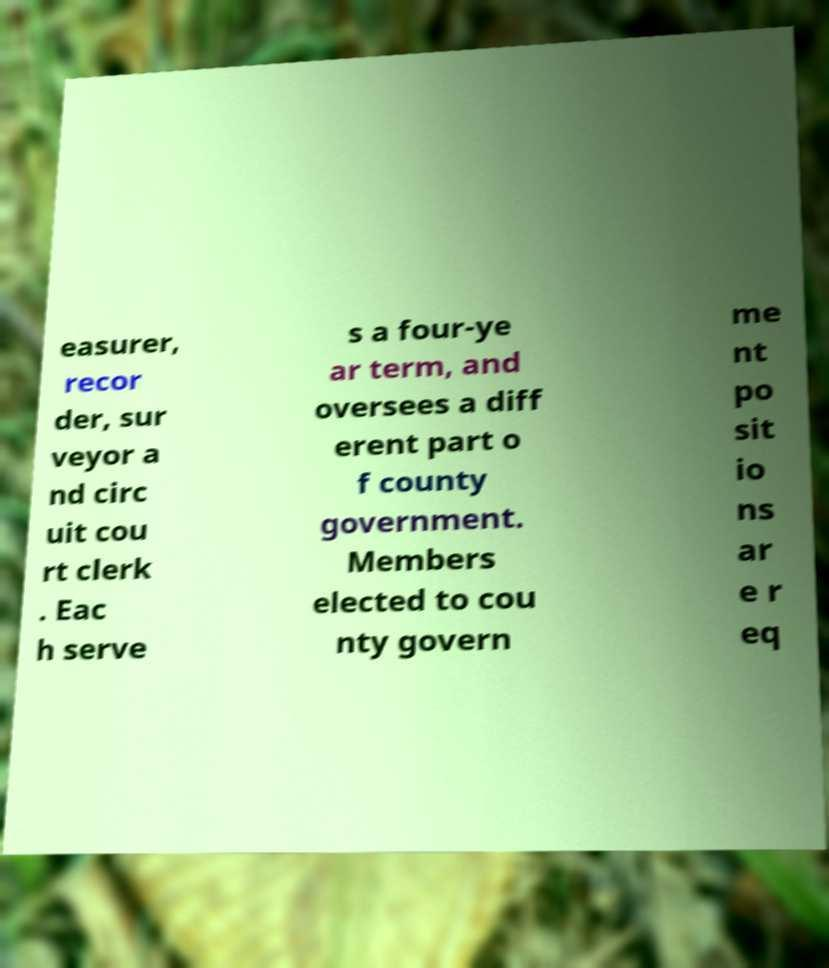There's text embedded in this image that I need extracted. Can you transcribe it verbatim? easurer, recor der, sur veyor a nd circ uit cou rt clerk . Eac h serve s a four-ye ar term, and oversees a diff erent part o f county government. Members elected to cou nty govern me nt po sit io ns ar e r eq 